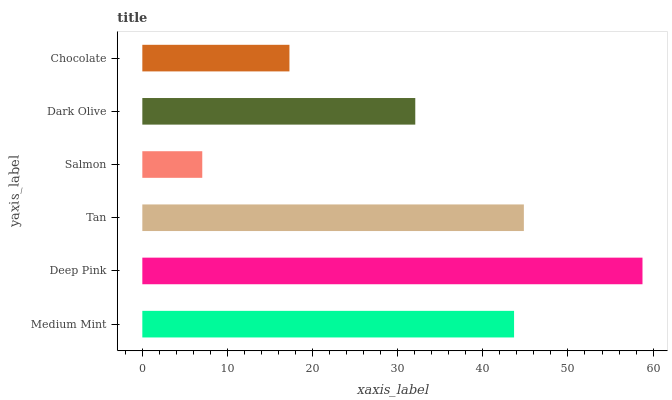Is Salmon the minimum?
Answer yes or no. Yes. Is Deep Pink the maximum?
Answer yes or no. Yes. Is Tan the minimum?
Answer yes or no. No. Is Tan the maximum?
Answer yes or no. No. Is Deep Pink greater than Tan?
Answer yes or no. Yes. Is Tan less than Deep Pink?
Answer yes or no. Yes. Is Tan greater than Deep Pink?
Answer yes or no. No. Is Deep Pink less than Tan?
Answer yes or no. No. Is Medium Mint the high median?
Answer yes or no. Yes. Is Dark Olive the low median?
Answer yes or no. Yes. Is Salmon the high median?
Answer yes or no. No. Is Tan the low median?
Answer yes or no. No. 